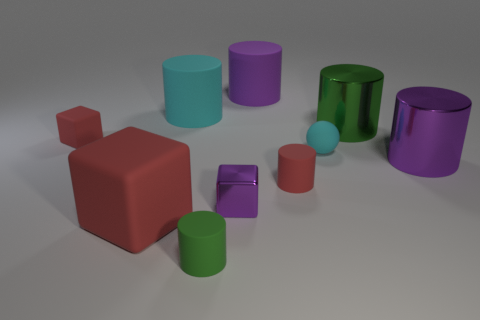Subtract all red cylinders. How many cylinders are left? 5 Subtract all green cylinders. How many cylinders are left? 4 Subtract 1 blocks. How many blocks are left? 2 Subtract all balls. How many objects are left? 9 Add 1 big things. How many big things exist? 6 Subtract 0 brown cylinders. How many objects are left? 10 Subtract all cyan blocks. Subtract all red cylinders. How many blocks are left? 3 Subtract all red cubes. How many purple balls are left? 0 Subtract all red cylinders. Subtract all big green shiny things. How many objects are left? 8 Add 3 green objects. How many green objects are left? 5 